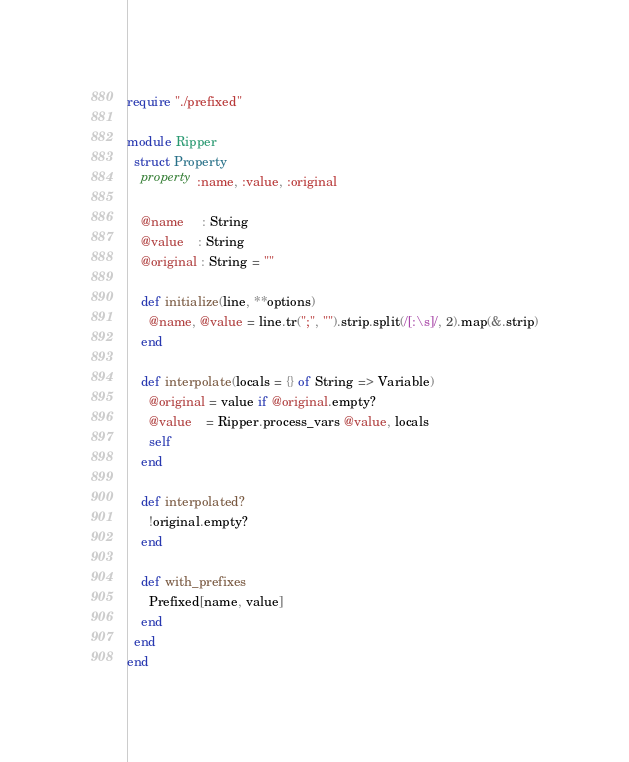Convert code to text. <code><loc_0><loc_0><loc_500><loc_500><_Crystal_>require "./prefixed"

module Ripper
  struct Property
    property :name, :value, :original

    @name     : String
    @value    : String
    @original : String = ""

    def initialize(line, **options)
      @name, @value = line.tr(";", "").strip.split(/[:\s]/, 2).map(&.strip)
    end

    def interpolate(locals = {} of String => Variable)
      @original = value if @original.empty?
      @value    = Ripper.process_vars @value, locals
      self
    end

    def interpolated?
      !original.empty?
    end

    def with_prefixes
      Prefixed[name, value]
    end
  end
end
</code> 